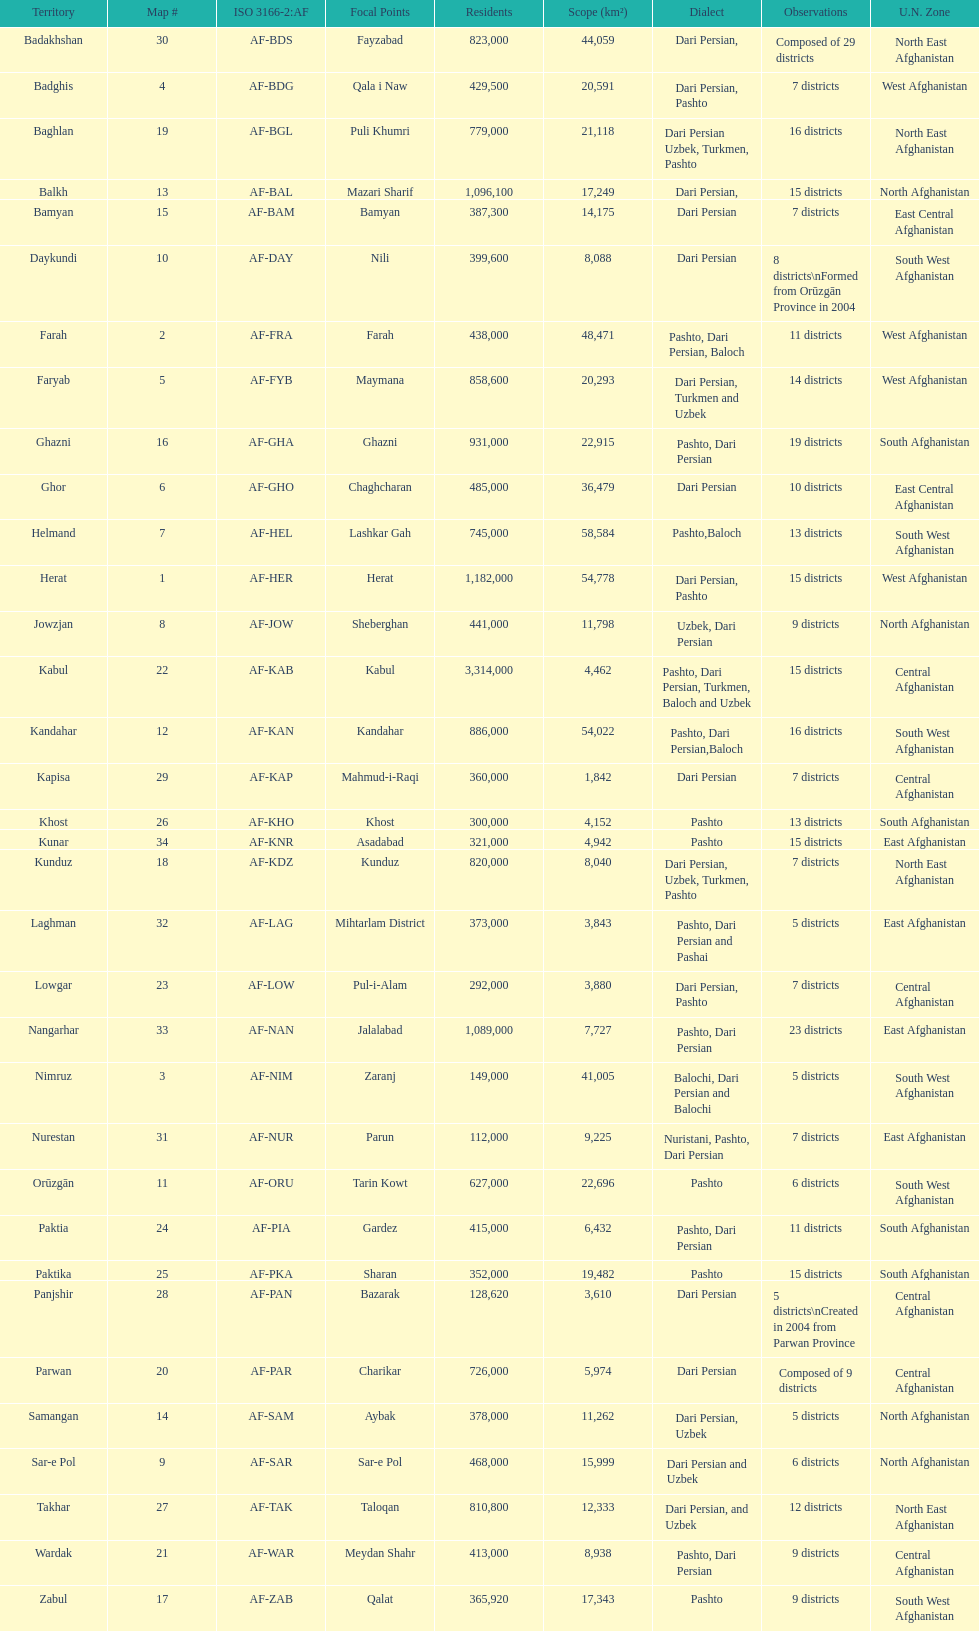How many provinces have pashto as one of their languages 20. 